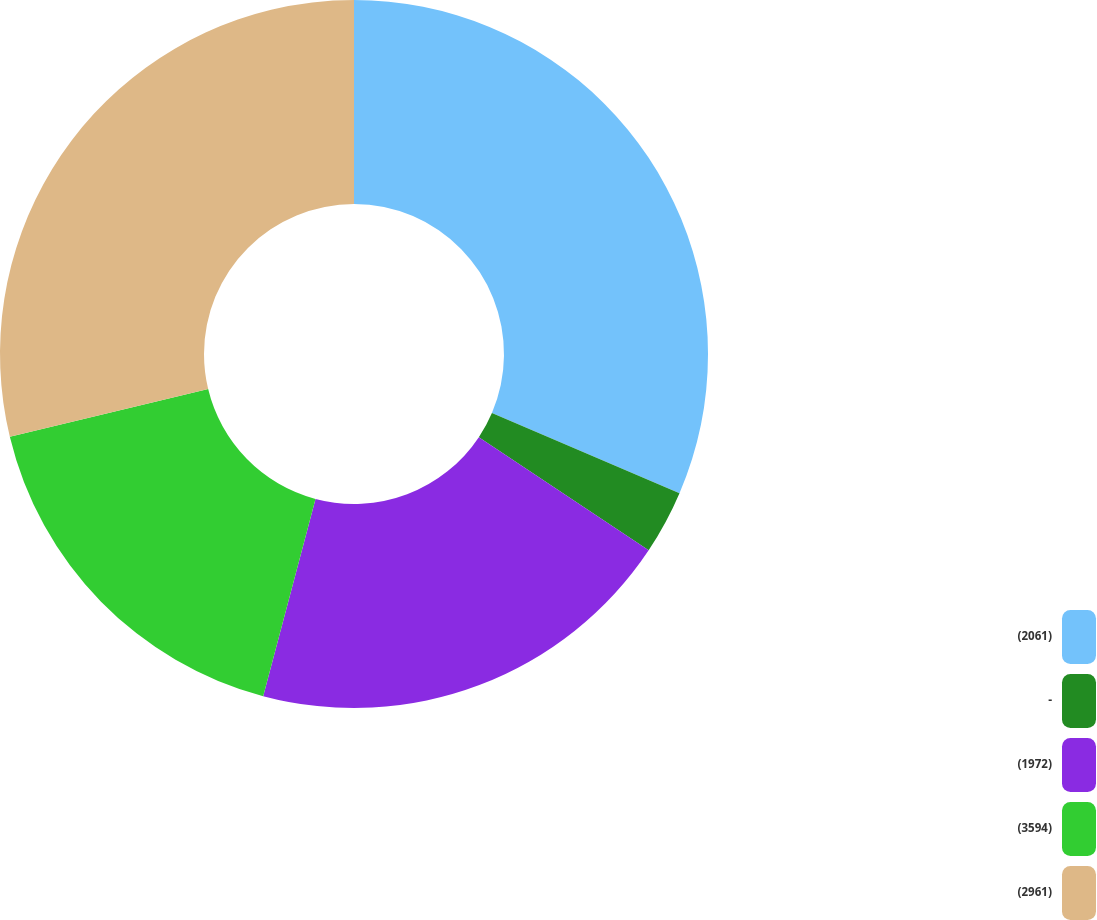Convert chart. <chart><loc_0><loc_0><loc_500><loc_500><pie_chart><fcel>(2061)<fcel>-<fcel>(1972)<fcel>(3594)<fcel>(2961)<nl><fcel>31.43%<fcel>2.92%<fcel>19.78%<fcel>17.11%<fcel>28.76%<nl></chart> 